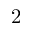<formula> <loc_0><loc_0><loc_500><loc_500>2</formula> 